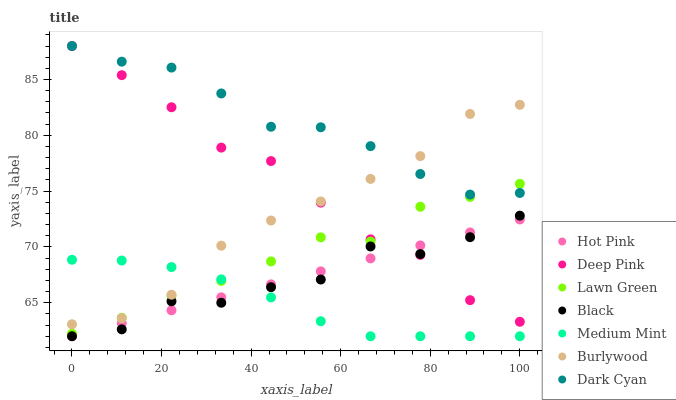Does Medium Mint have the minimum area under the curve?
Answer yes or no. Yes. Does Dark Cyan have the maximum area under the curve?
Answer yes or no. Yes. Does Lawn Green have the minimum area under the curve?
Answer yes or no. No. Does Lawn Green have the maximum area under the curve?
Answer yes or no. No. Is Hot Pink the smoothest?
Answer yes or no. Yes. Is Black the roughest?
Answer yes or no. Yes. Is Lawn Green the smoothest?
Answer yes or no. No. Is Lawn Green the roughest?
Answer yes or no. No. Does Medium Mint have the lowest value?
Answer yes or no. Yes. Does Lawn Green have the lowest value?
Answer yes or no. No. Does Dark Cyan have the highest value?
Answer yes or no. Yes. Does Lawn Green have the highest value?
Answer yes or no. No. Is Medium Mint less than Dark Cyan?
Answer yes or no. Yes. Is Deep Pink greater than Medium Mint?
Answer yes or no. Yes. Does Deep Pink intersect Hot Pink?
Answer yes or no. Yes. Is Deep Pink less than Hot Pink?
Answer yes or no. No. Is Deep Pink greater than Hot Pink?
Answer yes or no. No. Does Medium Mint intersect Dark Cyan?
Answer yes or no. No. 